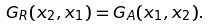Convert formula to latex. <formula><loc_0><loc_0><loc_500><loc_500>G _ { R } ( x _ { 2 } , x _ { 1 } ) = G _ { A } ( x _ { 1 } , x _ { 2 } ) .</formula> 